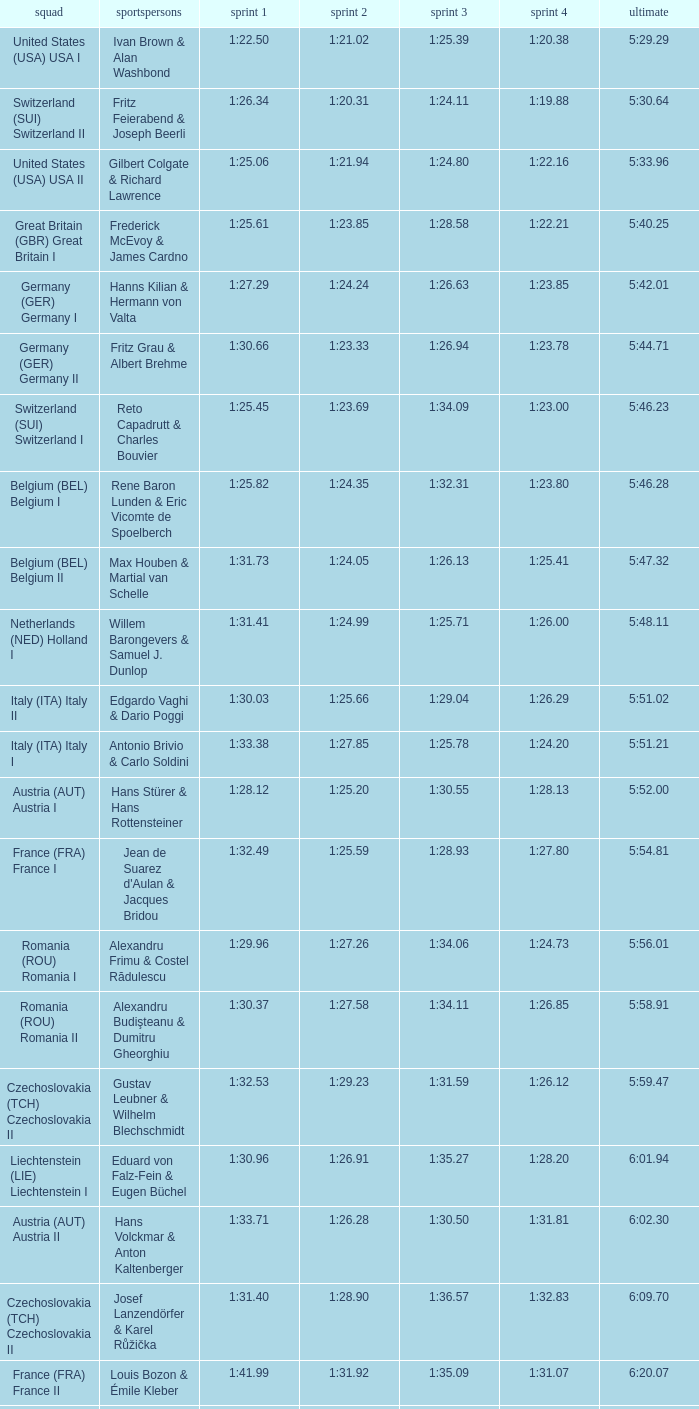Which Run 4 has a Run 3 of 1:26.63? 1:23.85. 